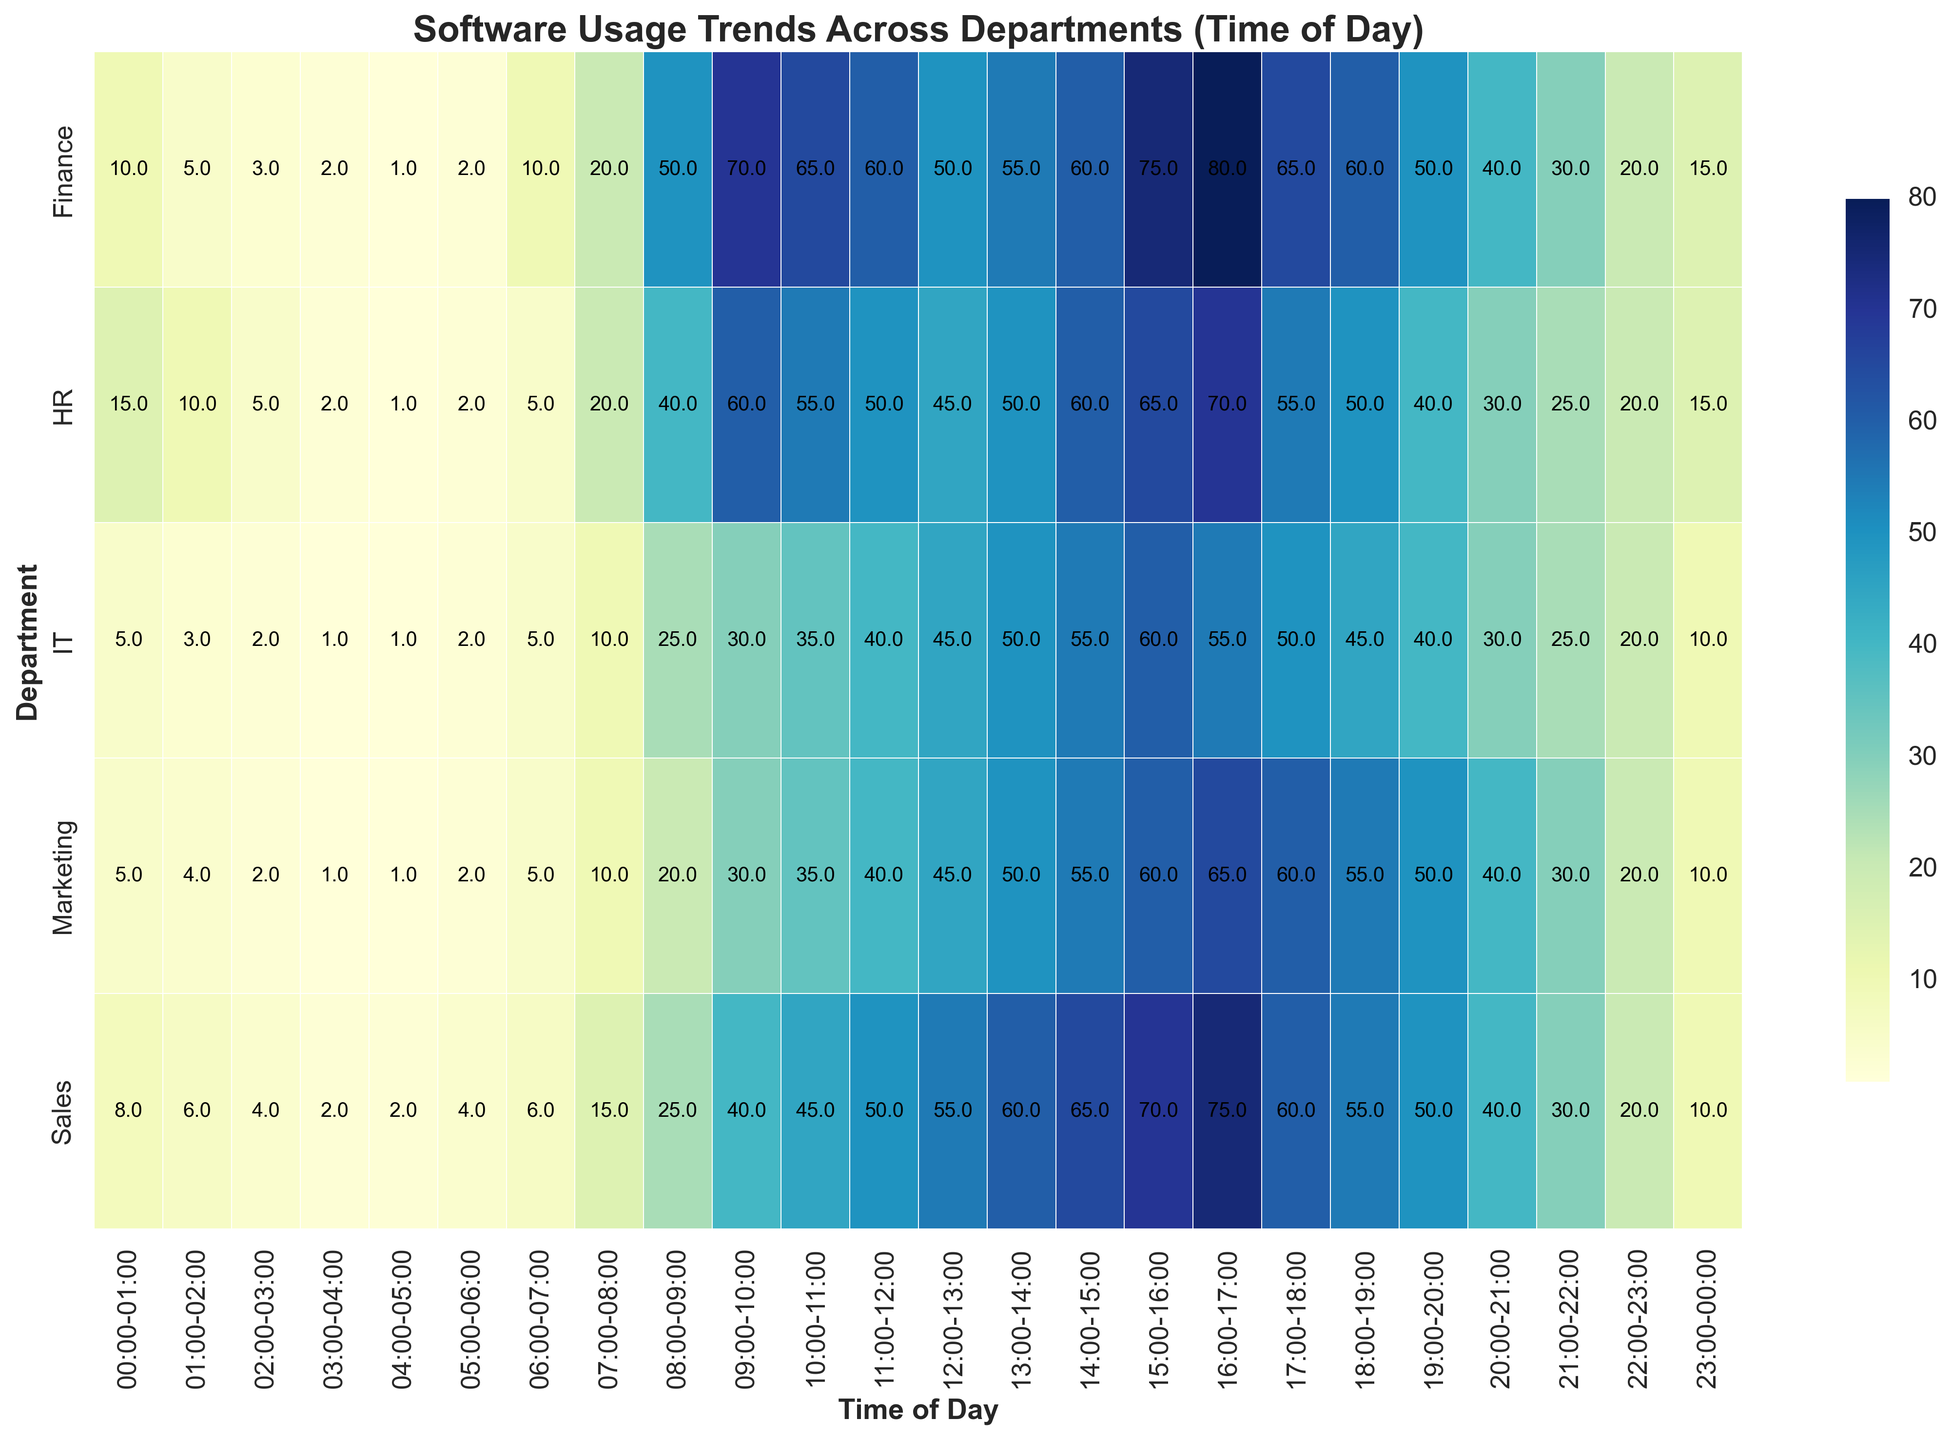What is the department with the highest software usage at 09:00-10:00? At 09:00-10:00, check the usage values for all departments. HR-Tool in HR has 60, Finance-Tool in Finance has 70, IT-Tool in IT has 30, CRM in Sales has 40, and SEO-Tool in Marketing has 30. Therefore, Finance department has the highest usage at this time.
Answer: Finance Which time slot has the lowest average software usage in the Marketing department? For each time slot, sum up the usages for the Marketing department and calculate the average. The time slot with the lowest average usage is found by checking the minimum value of these averages. Based on the data, the 03:00-04:00 and 04:00-05:00 slots both have an average usage of 1 for the Marketing department.
Answer: 03:00-04:00 and 04:00-05:00 Compare the software usage between HR and Sales at 16:00-17:00. Which department has higher usage? By how much? At 16:00-17:00, HR-Tool in HR has 70 and CRM in Sales has 75. Sales has higher usage by 75 - 70 = 5.
Answer: Sales by 5 What is the overall software usage trend in IT from 00:00 to 23:00? Look at the software usage values throughout the day for IT-Tool. The trend starts low, increases as the day progresses, peaking at 15:00-16:00 with 60, and then gradually decreases towards the end of the day.
Answer: Increasing initially, peaks, then decreases Which department shows the most consistent software usage throughout the day? Consistency can be observed by looking for smaller variance in usage values. The department with the least variation in heights would be IT, as its usage remains relatively steady with slight increases and decreases throughout the day.
Answer: IT Which software is used most and least during 06:00-07:00 across all departments? Check the usage for each department at 06:00-07:00. HR-Tool in HR has 5, Finance-Tool in Finance has 10, IT-Tool in IT has 5, CRM in Sales has 6, and SEO-Tool in Marketing has 5. Finance-Tool is used the most with 10 and HR-Tool, IT-Tool, and SEO-Tool are all used the least with 5.
Answer: Most: Finance-Tool, Least: HR-Tool, IT-Tool, and SEO-Tool 